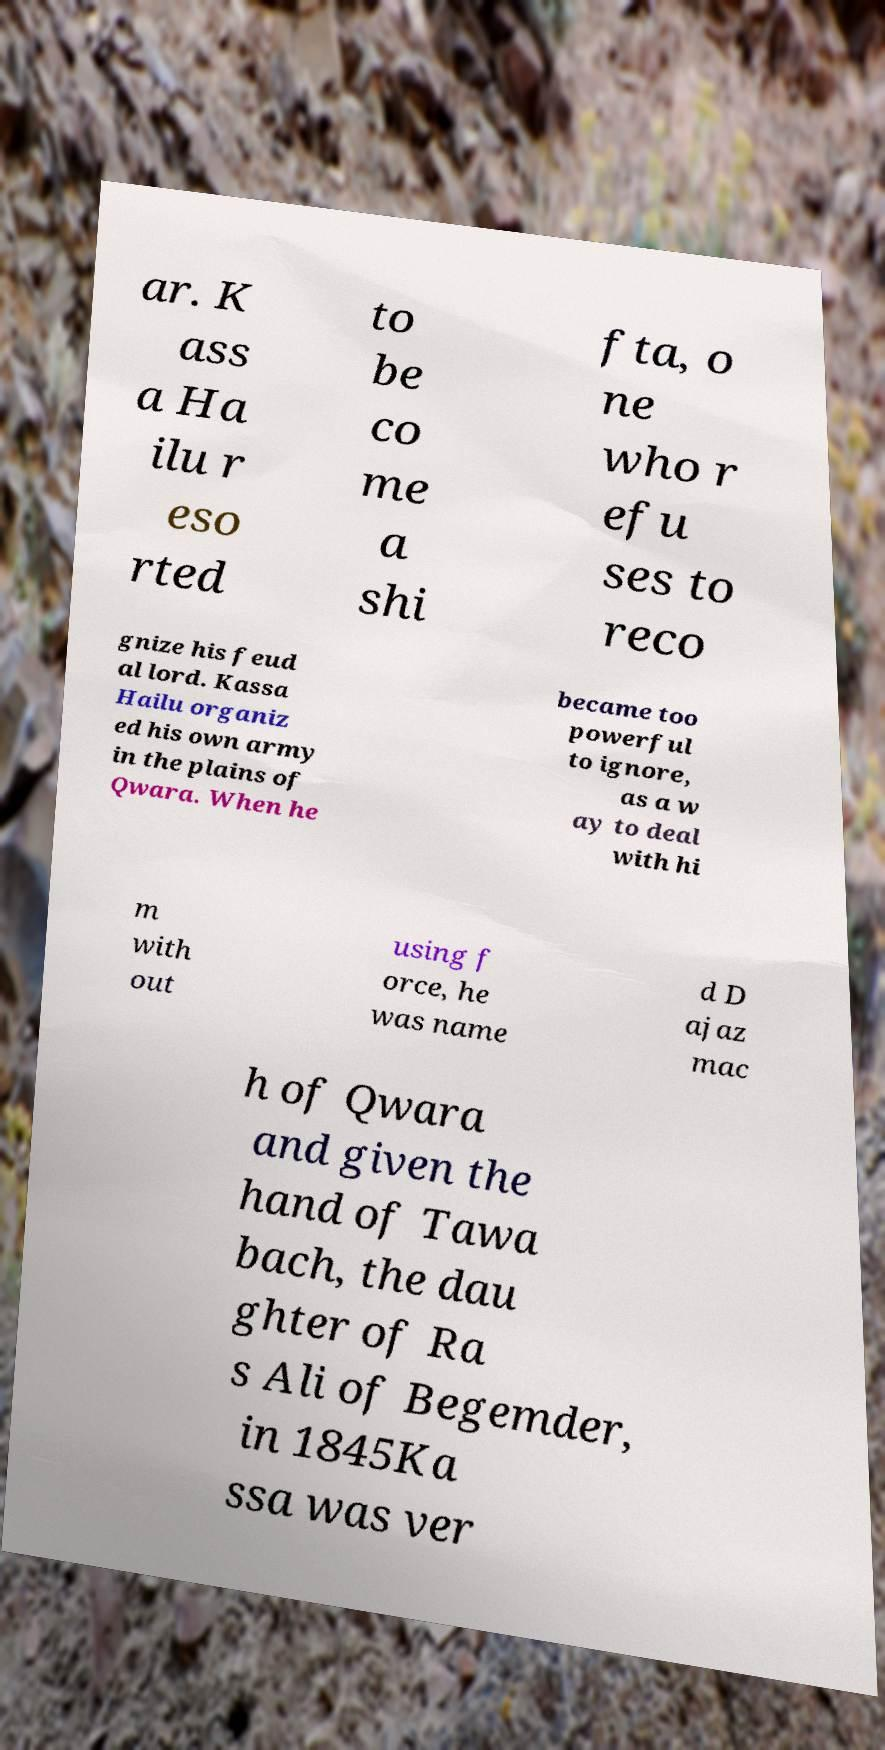Could you assist in decoding the text presented in this image and type it out clearly? ar. K ass a Ha ilu r eso rted to be co me a shi fta, o ne who r efu ses to reco gnize his feud al lord. Kassa Hailu organiz ed his own army in the plains of Qwara. When he became too powerful to ignore, as a w ay to deal with hi m with out using f orce, he was name d D ajaz mac h of Qwara and given the hand of Tawa bach, the dau ghter of Ra s Ali of Begemder, in 1845Ka ssa was ver 